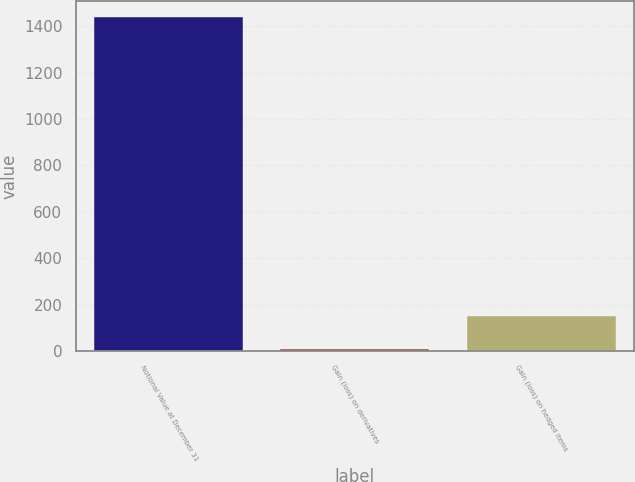<chart> <loc_0><loc_0><loc_500><loc_500><bar_chart><fcel>Notional Value at December 31<fcel>Gain (loss) on derivatives<fcel>Gain (loss) on hedged items<nl><fcel>1438<fcel>8<fcel>151<nl></chart> 